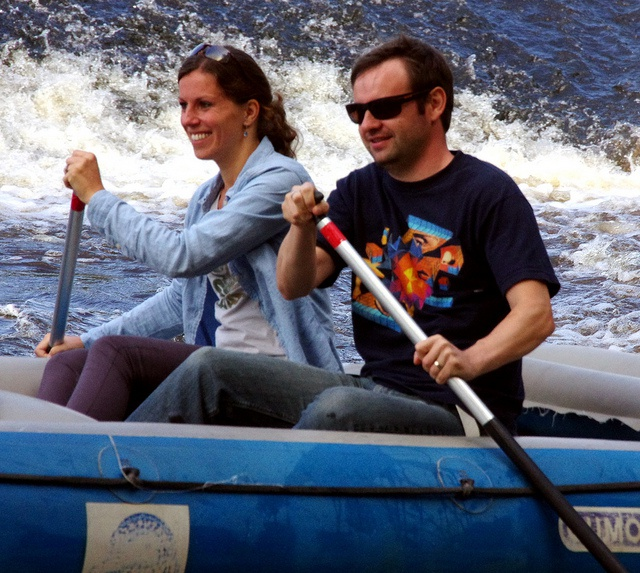Describe the objects in this image and their specific colors. I can see boat in black, navy, blue, and darkgray tones, people in black, maroon, gray, and brown tones, and people in black, gray, and darkgray tones in this image. 